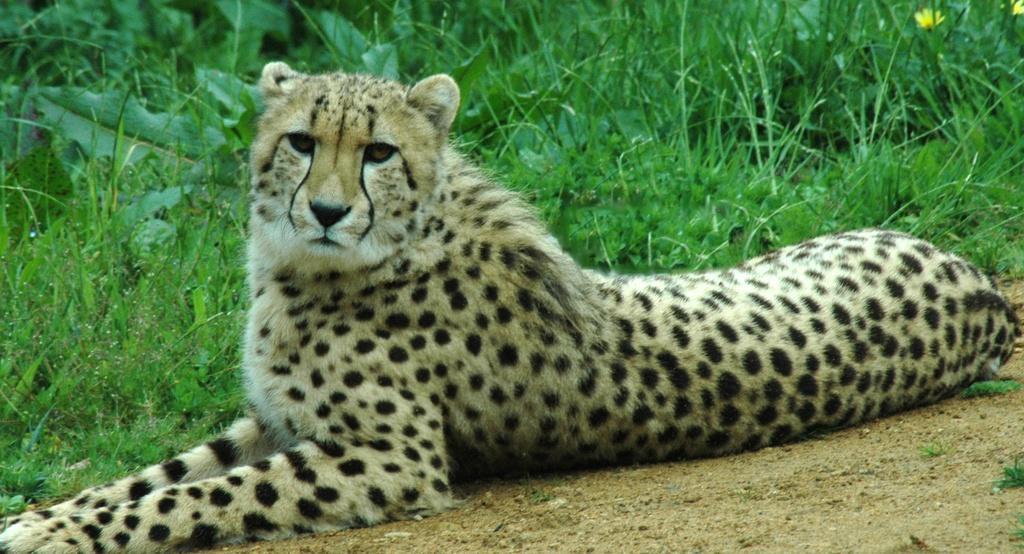Describe this image in one or two sentences. In the center of the image we can see one cheetah, which is in black and cream color. In the background, we can see the grass, flowers and a few other objects. 